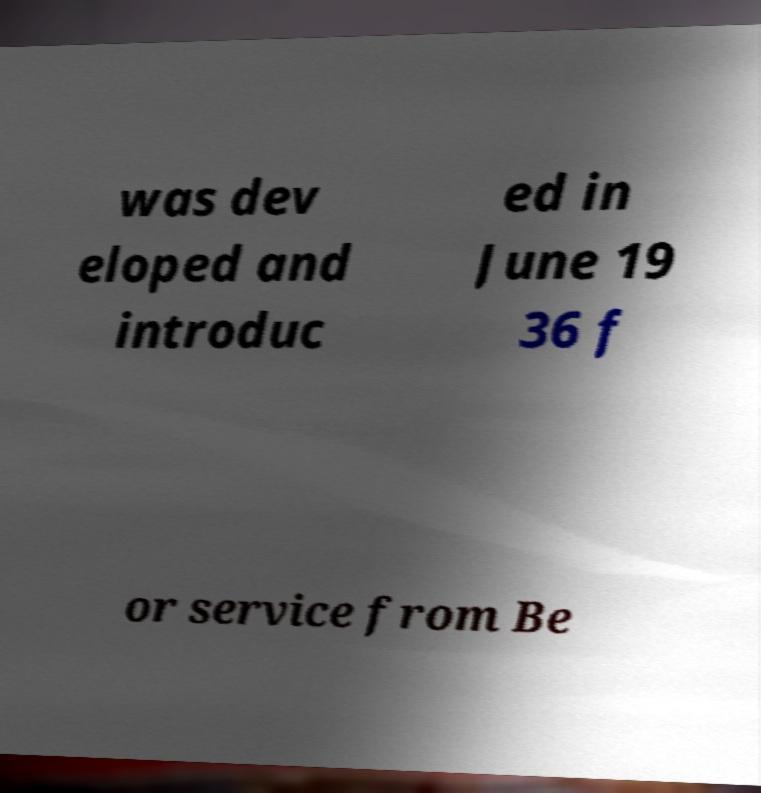What messages or text are displayed in this image? I need them in a readable, typed format. was dev eloped and introduc ed in June 19 36 f or service from Be 